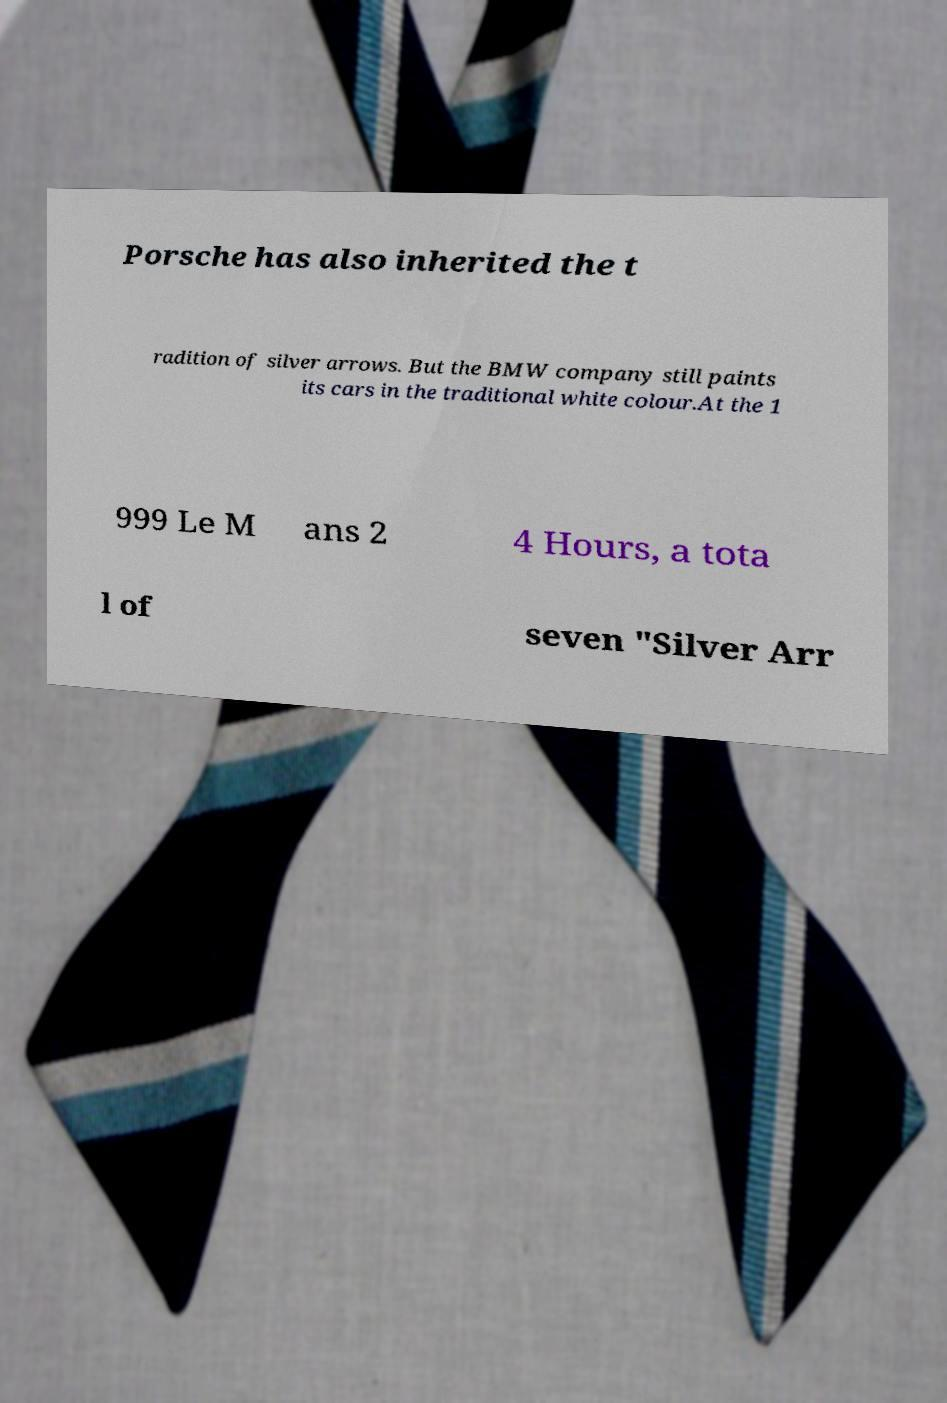I need the written content from this picture converted into text. Can you do that? Porsche has also inherited the t radition of silver arrows. But the BMW company still paints its cars in the traditional white colour.At the 1 999 Le M ans 2 4 Hours, a tota l of seven "Silver Arr 